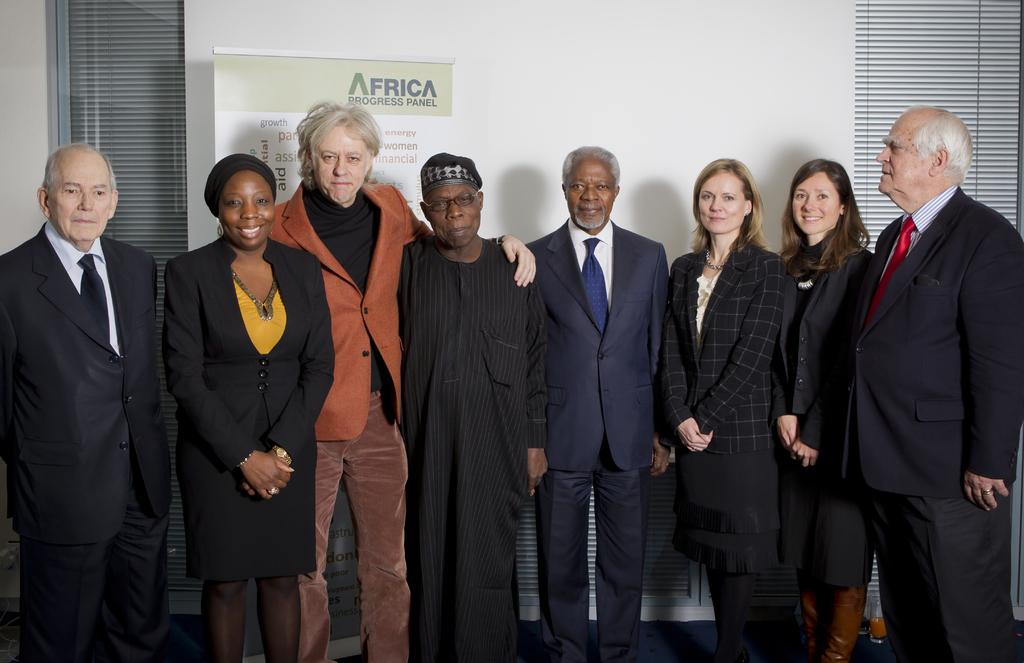How many people are in the image? There is a group of persons standing in the image. Where are the persons standing? The persons are standing on the floor. What can be seen in the background of the image? There is a curtain, windows, an advertisement, and a wall in the background of the image. What type of representative can be seen in the image? There is no representative present in the image; it features a group of persons standing on the floor. What specific detail can be observed on the wall in the image? The provided facts do not mention any specific details on the wall; only that there is a wall in the background of the image. 